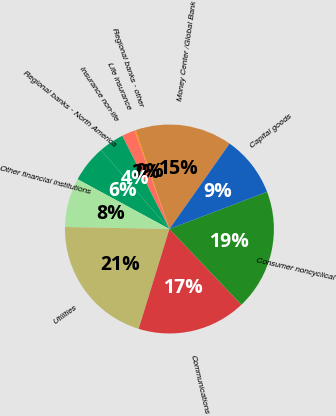<chart> <loc_0><loc_0><loc_500><loc_500><pie_chart><fcel>Money Center /Global Bank<fcel>Regional banks - other<fcel>Life insurance<fcel>Insurance non-life<fcel>Regional banks - North America<fcel>Other financial institutions<fcel>Utilities<fcel>Communications<fcel>Consumer noncyclical<fcel>Capital goods<nl><fcel>15.0%<fcel>0.19%<fcel>2.04%<fcel>3.89%<fcel>5.74%<fcel>7.59%<fcel>20.55%<fcel>16.85%<fcel>18.7%<fcel>9.44%<nl></chart> 